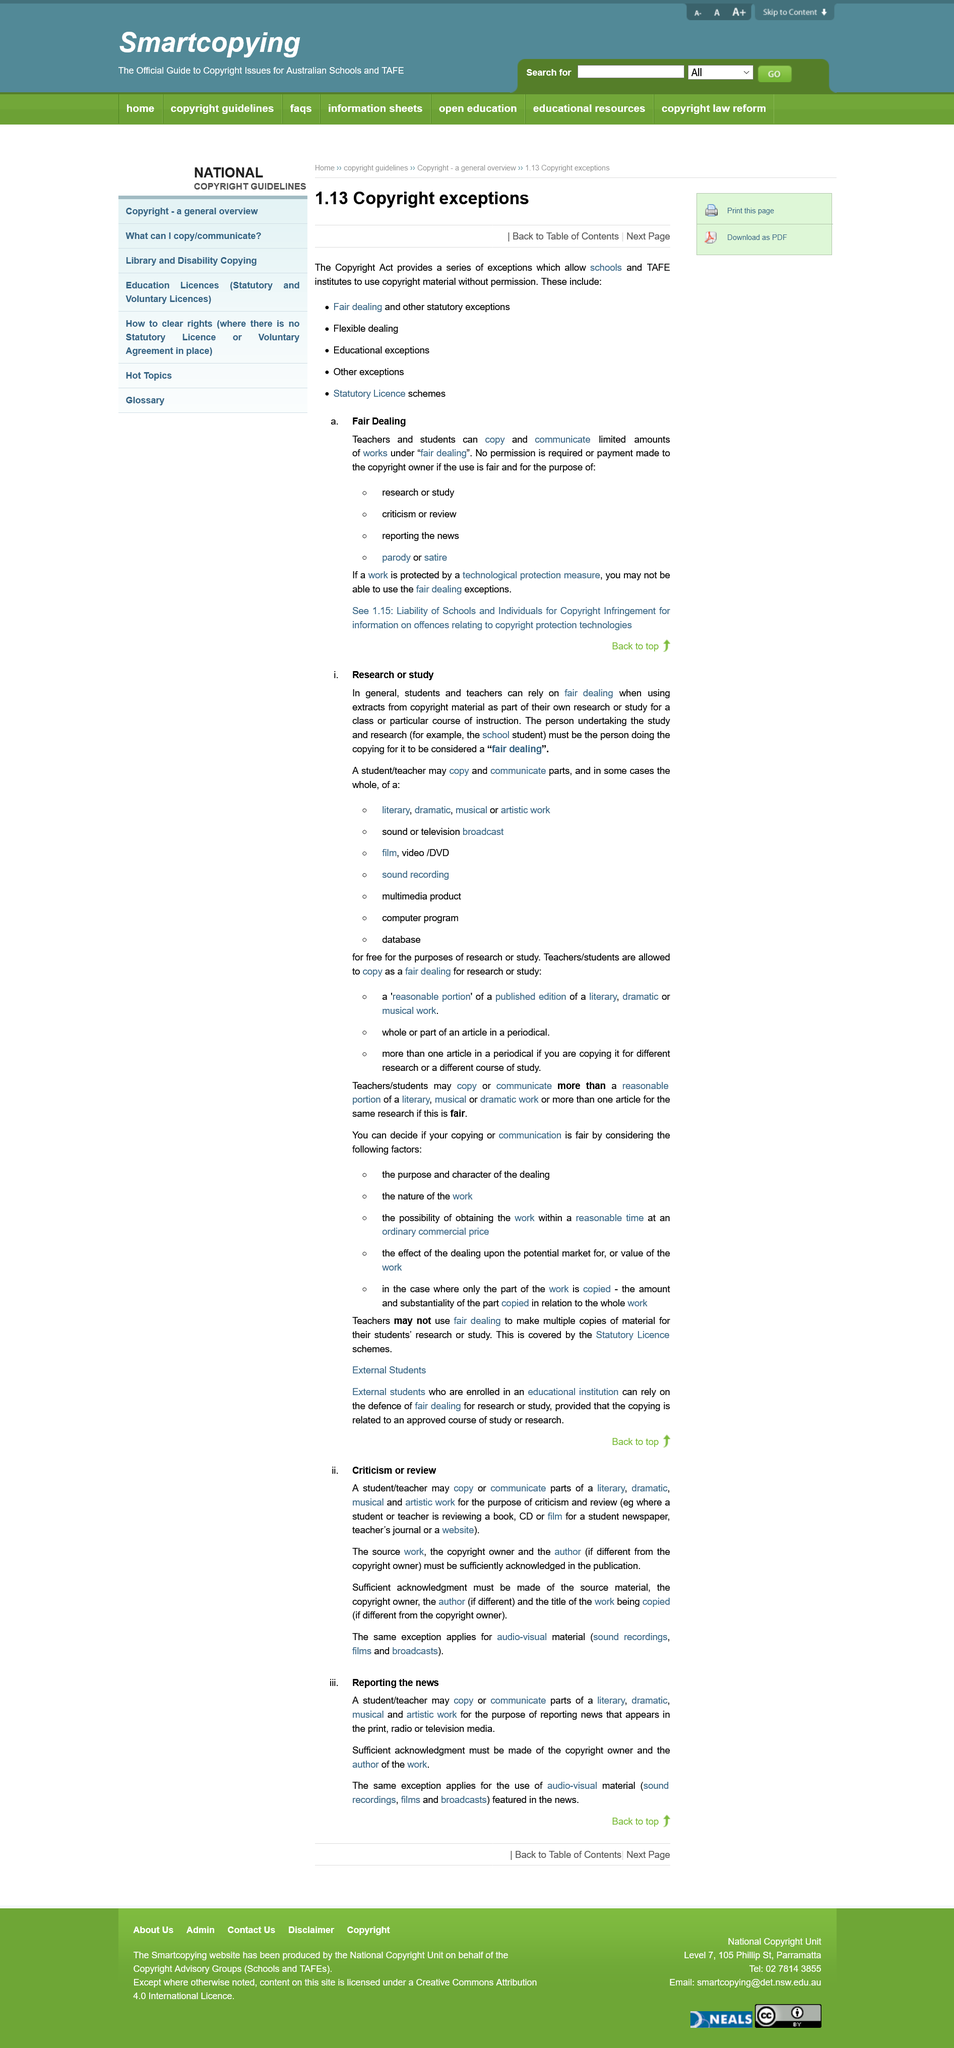Indicate a few pertinent items in this graphic. The acknowledgment of the copyright and author of the work for audio-visual material, sound recordings, film and broadcasts is required as well. The same acknowledgment is needed for audio-visual material, sound recordings, film and broadcasts. Some examples of criticism and review involve students or teachers evaluating books, CDs, or films for student newspapers, teacher's journals, or websites. A student or teacher may copy or communicate parts of a literary, dramatic, musical, and artistic work for the purpose of criticism and review. It is necessary to seek acknowledgement from the copyright owner and the author of the work. Sufficient acknowledgement must be made of the source material. 